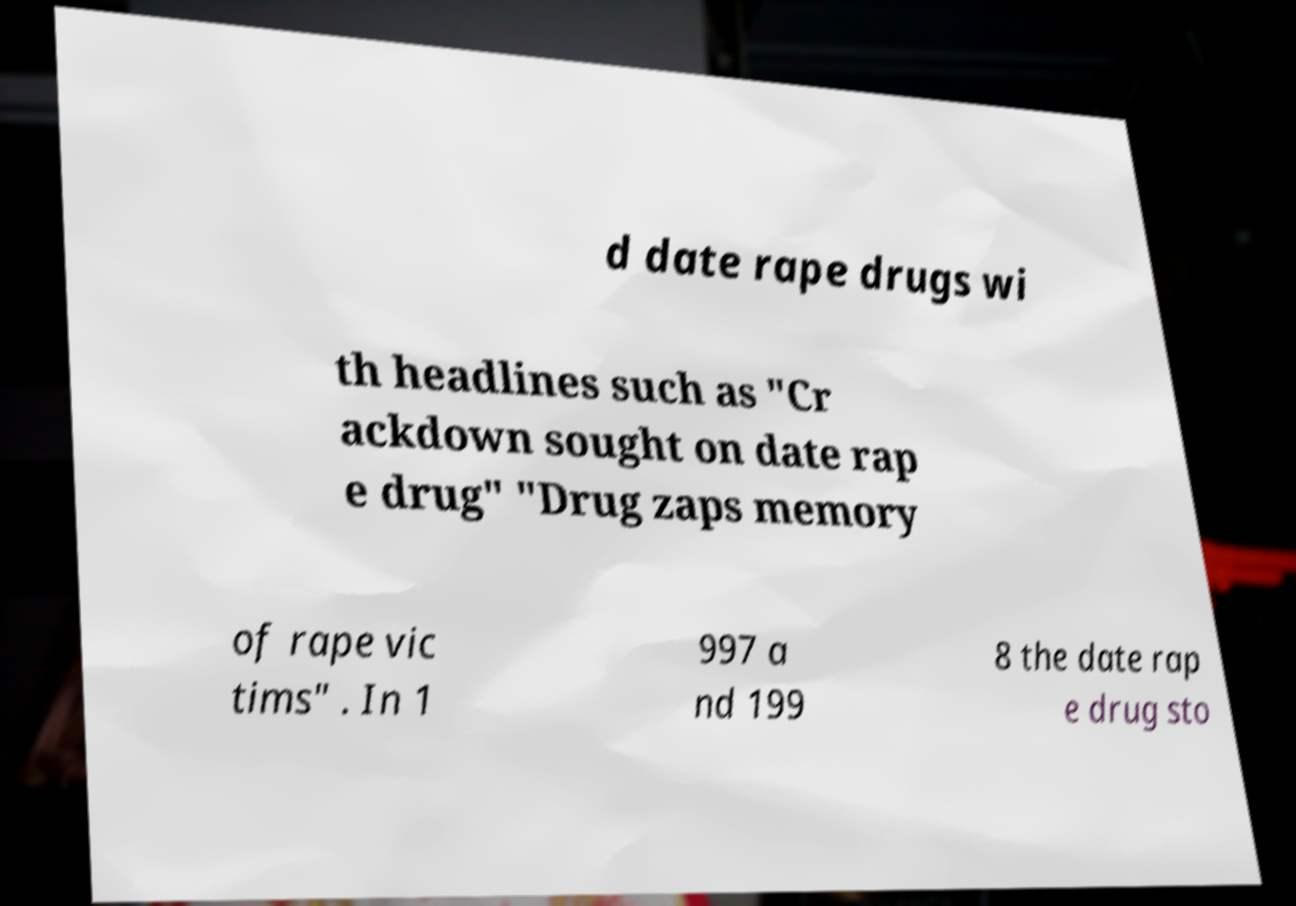Please read and relay the text visible in this image. What does it say? d date rape drugs wi th headlines such as "Cr ackdown sought on date rap e drug" "Drug zaps memory of rape vic tims" . In 1 997 a nd 199 8 the date rap e drug sto 